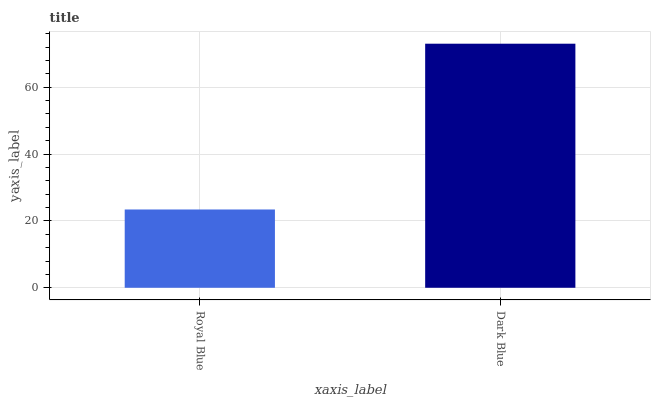Is Dark Blue the minimum?
Answer yes or no. No. Is Dark Blue greater than Royal Blue?
Answer yes or no. Yes. Is Royal Blue less than Dark Blue?
Answer yes or no. Yes. Is Royal Blue greater than Dark Blue?
Answer yes or no. No. Is Dark Blue less than Royal Blue?
Answer yes or no. No. Is Dark Blue the high median?
Answer yes or no. Yes. Is Royal Blue the low median?
Answer yes or no. Yes. Is Royal Blue the high median?
Answer yes or no. No. Is Dark Blue the low median?
Answer yes or no. No. 